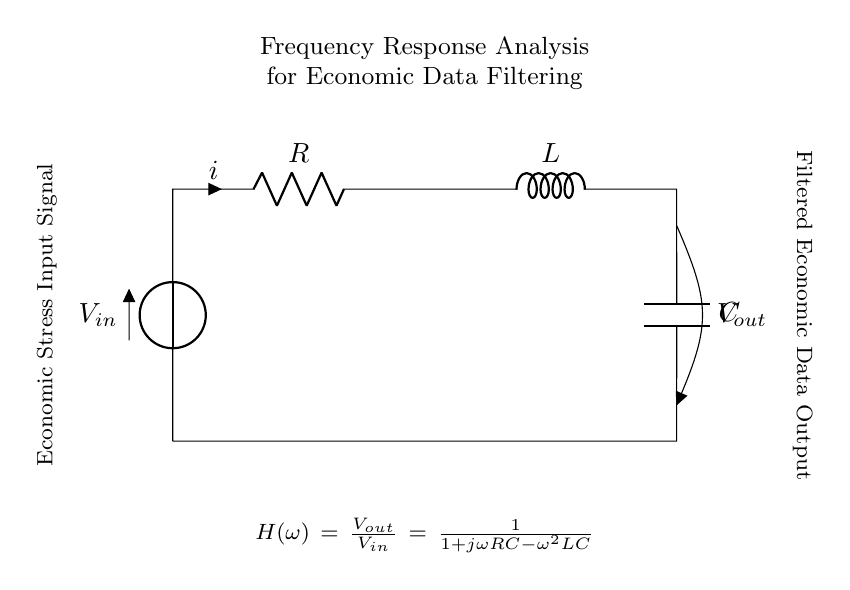What is the input voltage in this circuit? The input voltage, represented as V_subscript_in, is located at the top left of the circuit. It signifies the voltage supplied to the circuit before filtering.
Answer: V_in What is the output voltage in this circuit? The output voltage, represented as V_subscript_out, is situated at the upper right side of the circuit. It indicates the voltage after passing through the RLC components.
Answer: V_out What type of circuit is this? This circuit is an RLC circuit, which includes a resistor, an inductor, and a capacitor arranged in series.
Answer: RLC What does the transfer function H(ω) represent? The transfer function H(ω) describes the frequency response of the circuit, providing a mathematical relationship between the input and output voltages as a function of angular frequency.
Answer: Frequency response How does increasing the resistance R affect the frequency response? Increasing R will generally decrease the bandwidth of the circuit, causing it to respond more slowly to changes in the input signal. The transfer function will indicate a larger damping effect, leading to a smoother output.
Answer: Decreases bandwidth What is the mathematical form of the output voltage in relation to input voltage? The output voltage V_out is given by the transfer function H(ω) multiplied by the input voltage V_in, expressed as V_out = H(ω) * V_in where H(ω) is detailed in the circuit.
Answer: V_out = H(ω) * V_in What role does the capacitor play in this circuit? The capacitor stores electrical energy and affects the phase and frequency response of the circuit. It allows AC signals to pass while blocking DC, thus shaping the output voltage based on frequency components.
Answer: Energy storage 